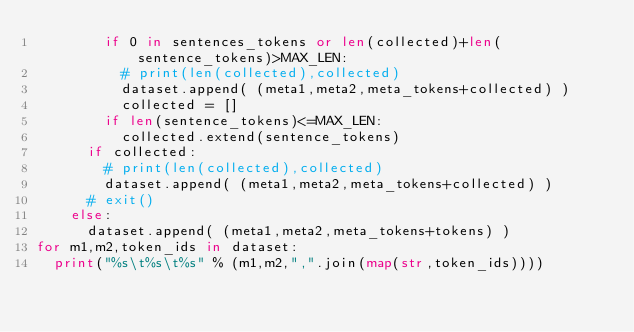Convert code to text. <code><loc_0><loc_0><loc_500><loc_500><_Python_>				if 0 in sentences_tokens or len(collected)+len(sentence_tokens)>MAX_LEN:
					# print(len(collected),collected)
					dataset.append( (meta1,meta2,meta_tokens+collected) )
					collected = []
				if len(sentence_tokens)<=MAX_LEN:
					collected.extend(sentence_tokens)
			if collected:
				# print(len(collected),collected)
				dataset.append( (meta1,meta2,meta_tokens+collected) )
			# exit()
		else:
			dataset.append( (meta1,meta2,meta_tokens+tokens) )
for m1,m2,token_ids in dataset:
	print("%s\t%s\t%s" % (m1,m2,",".join(map(str,token_ids))))
</code> 